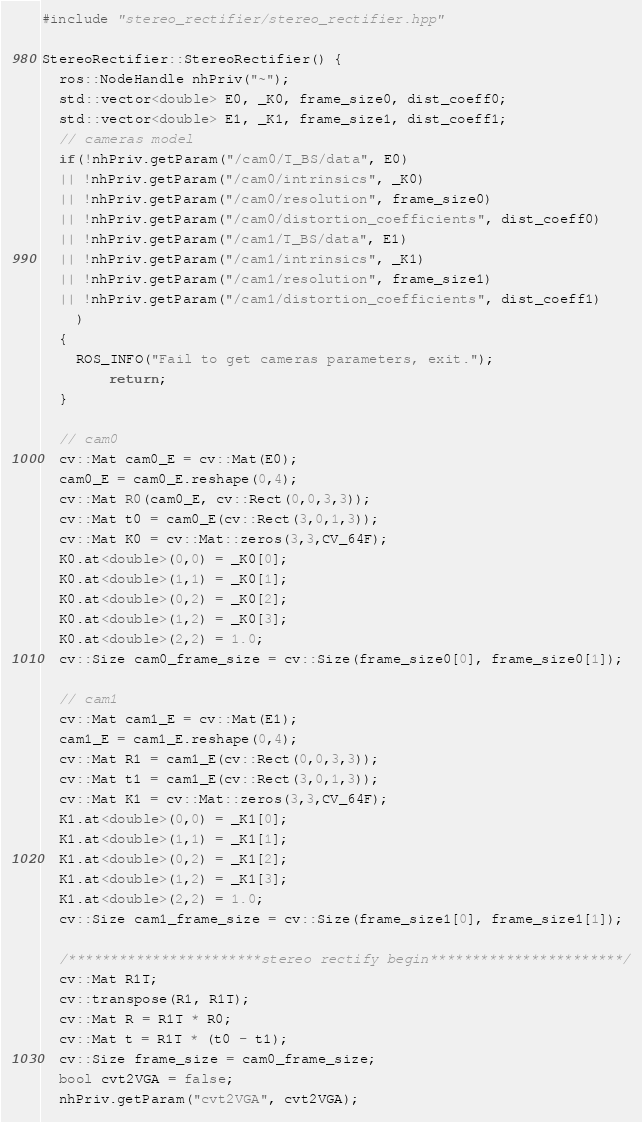<code> <loc_0><loc_0><loc_500><loc_500><_C++_>#include "stereo_rectifier/stereo_rectifier.hpp"

StereoRectifier::StereoRectifier() {
  ros::NodeHandle nhPriv("~");
  std::vector<double> E0, _K0, frame_size0, dist_coeff0;
  std::vector<double> E1, _K1, frame_size1, dist_coeff1;
  // cameras model
  if(!nhPriv.getParam("/cam0/T_BS/data", E0)
  || !nhPriv.getParam("/cam0/intrinsics", _K0)
  || !nhPriv.getParam("/cam0/resolution", frame_size0)
  || !nhPriv.getParam("/cam0/distortion_coefficients", dist_coeff0)
  || !nhPriv.getParam("/cam1/T_BS/data", E1)
  || !nhPriv.getParam("/cam1/intrinsics", _K1)
  || !nhPriv.getParam("/cam1/resolution", frame_size1)
  || !nhPriv.getParam("/cam1/distortion_coefficients", dist_coeff1)
    )
  {
    ROS_INFO("Fail to get cameras parameters, exit.");
        return;
  }

  // cam0
  cv::Mat cam0_E = cv::Mat(E0);
  cam0_E = cam0_E.reshape(0,4);
  cv::Mat R0(cam0_E, cv::Rect(0,0,3,3));
  cv::Mat t0 = cam0_E(cv::Rect(3,0,1,3));
  cv::Mat K0 = cv::Mat::zeros(3,3,CV_64F);
  K0.at<double>(0,0) = _K0[0];
  K0.at<double>(1,1) = _K0[1];
  K0.at<double>(0,2) = _K0[2];
  K0.at<double>(1,2) = _K0[3];
  K0.at<double>(2,2) = 1.0;
  cv::Size cam0_frame_size = cv::Size(frame_size0[0], frame_size0[1]);

  // cam1
  cv::Mat cam1_E = cv::Mat(E1);
  cam1_E = cam1_E.reshape(0,4);
  cv::Mat R1 = cam1_E(cv::Rect(0,0,3,3));
  cv::Mat t1 = cam1_E(cv::Rect(3,0,1,3));
  cv::Mat K1 = cv::Mat::zeros(3,3,CV_64F);
  K1.at<double>(0,0) = _K1[0];
  K1.at<double>(1,1) = _K1[1];
  K1.at<double>(0,2) = _K1[2];
  K1.at<double>(1,2) = _K1[3];
  K1.at<double>(2,2) = 1.0;
  cv::Size cam1_frame_size = cv::Size(frame_size1[0], frame_size1[1]);

  /***********************stereo rectify begin***********************/
  cv::Mat R1T;
  cv::transpose(R1, R1T);
  cv::Mat R = R1T * R0;
  cv::Mat t = R1T * (t0 - t1);
  cv::Size frame_size = cam0_frame_size;
  bool cvt2VGA = false;
  nhPriv.getParam("cvt2VGA", cvt2VGA);</code> 